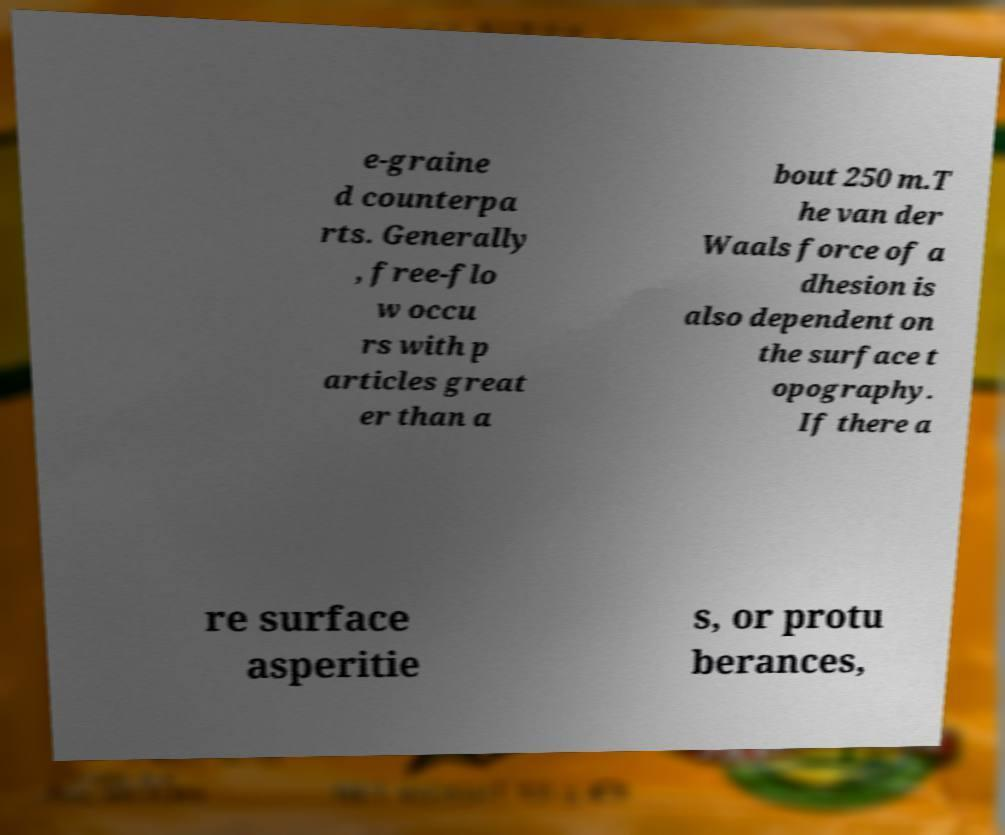For documentation purposes, I need the text within this image transcribed. Could you provide that? e-graine d counterpa rts. Generally , free-flo w occu rs with p articles great er than a bout 250 m.T he van der Waals force of a dhesion is also dependent on the surface t opography. If there a re surface asperitie s, or protu berances, 